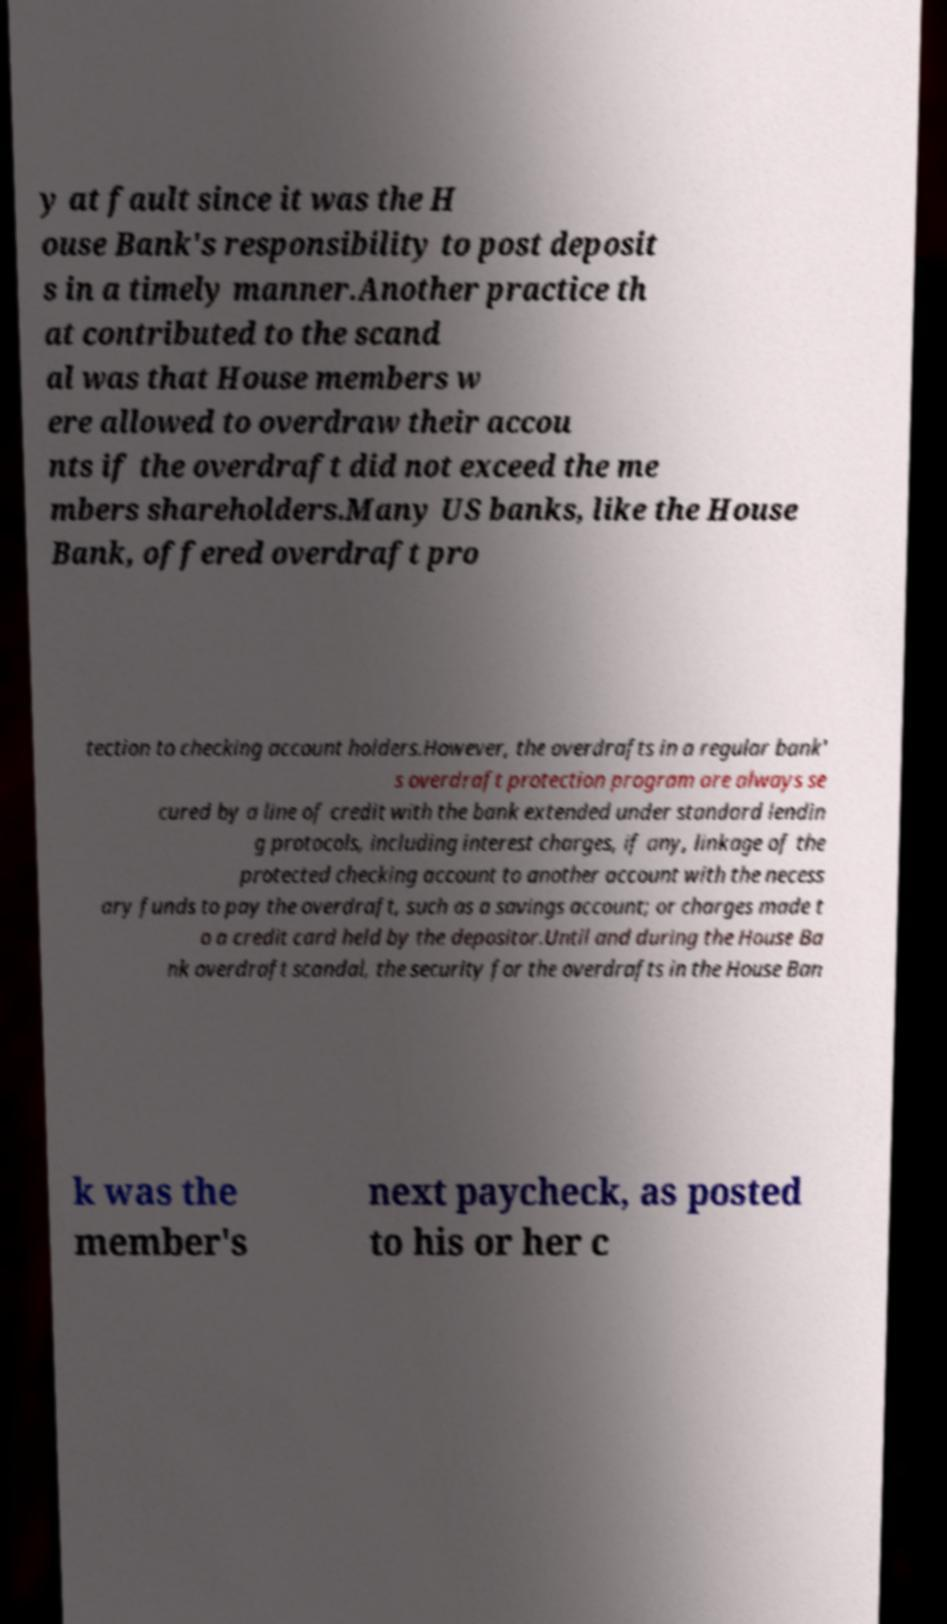Please identify and transcribe the text found in this image. y at fault since it was the H ouse Bank's responsibility to post deposit s in a timely manner.Another practice th at contributed to the scand al was that House members w ere allowed to overdraw their accou nts if the overdraft did not exceed the me mbers shareholders.Many US banks, like the House Bank, offered overdraft pro tection to checking account holders.However, the overdrafts in a regular bank' s overdraft protection program are always se cured by a line of credit with the bank extended under standard lendin g protocols, including interest charges, if any, linkage of the protected checking account to another account with the necess ary funds to pay the overdraft, such as a savings account; or charges made t o a credit card held by the depositor.Until and during the House Ba nk overdraft scandal, the security for the overdrafts in the House Ban k was the member's next paycheck, as posted to his or her c 